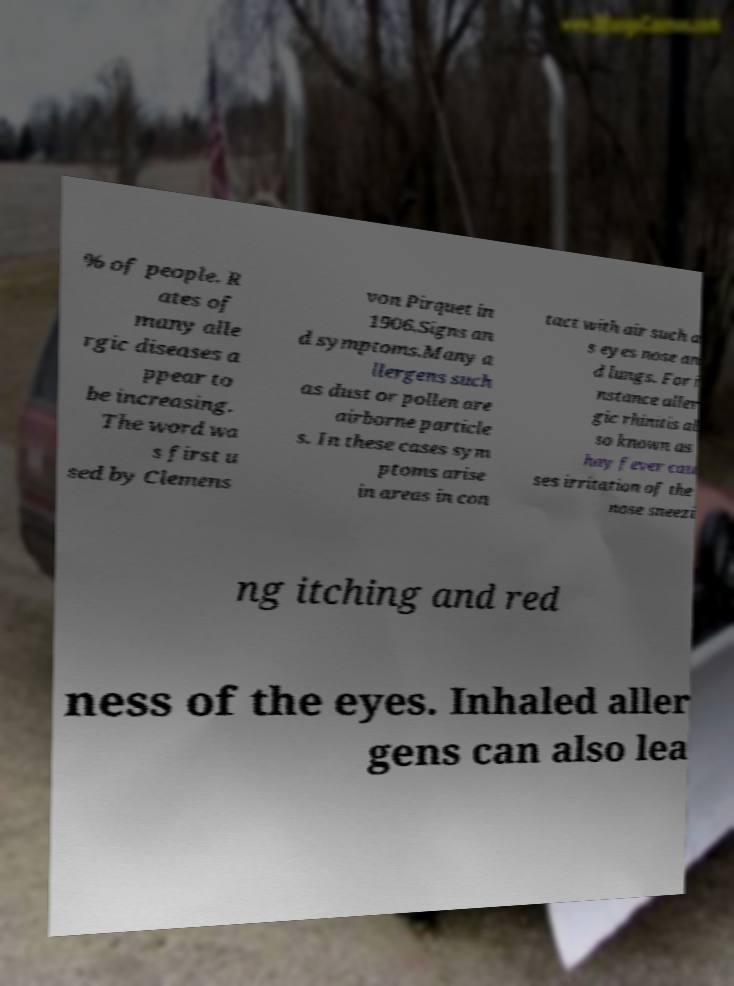What messages or text are displayed in this image? I need them in a readable, typed format. % of people. R ates of many alle rgic diseases a ppear to be increasing. The word wa s first u sed by Clemens von Pirquet in 1906.Signs an d symptoms.Many a llergens such as dust or pollen are airborne particle s. In these cases sym ptoms arise in areas in con tact with air such a s eyes nose an d lungs. For i nstance aller gic rhinitis al so known as hay fever cau ses irritation of the nose sneezi ng itching and red ness of the eyes. Inhaled aller gens can also lea 